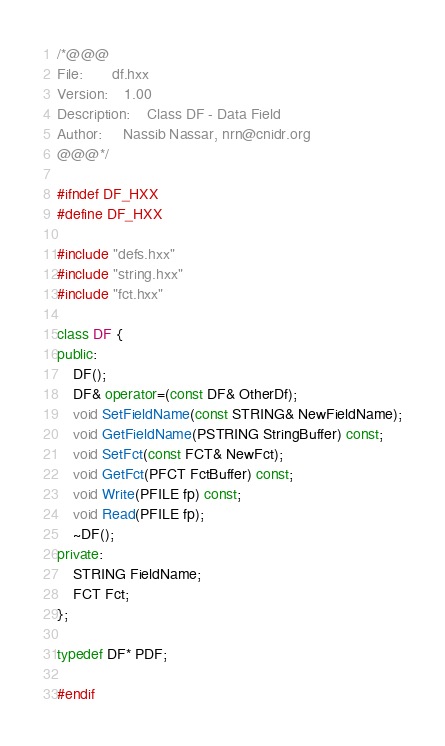<code> <loc_0><loc_0><loc_500><loc_500><_C++_>/*@@@
File:		df.hxx
Version:	1.00
Description:	Class DF - Data Field
Author:		Nassib Nassar, nrn@cnidr.org
@@@*/

#ifndef DF_HXX
#define DF_HXX

#include "defs.hxx"
#include "string.hxx"
#include "fct.hxx"

class DF {
public:
	DF();
	DF& operator=(const DF& OtherDf);
	void SetFieldName(const STRING& NewFieldName);
	void GetFieldName(PSTRING StringBuffer) const;
	void SetFct(const FCT& NewFct);
	void GetFct(PFCT FctBuffer) const;
	void Write(PFILE fp) const;
	void Read(PFILE fp);
	~DF();
private:
	STRING FieldName;
	FCT Fct;
};

typedef DF* PDF;

#endif
</code> 